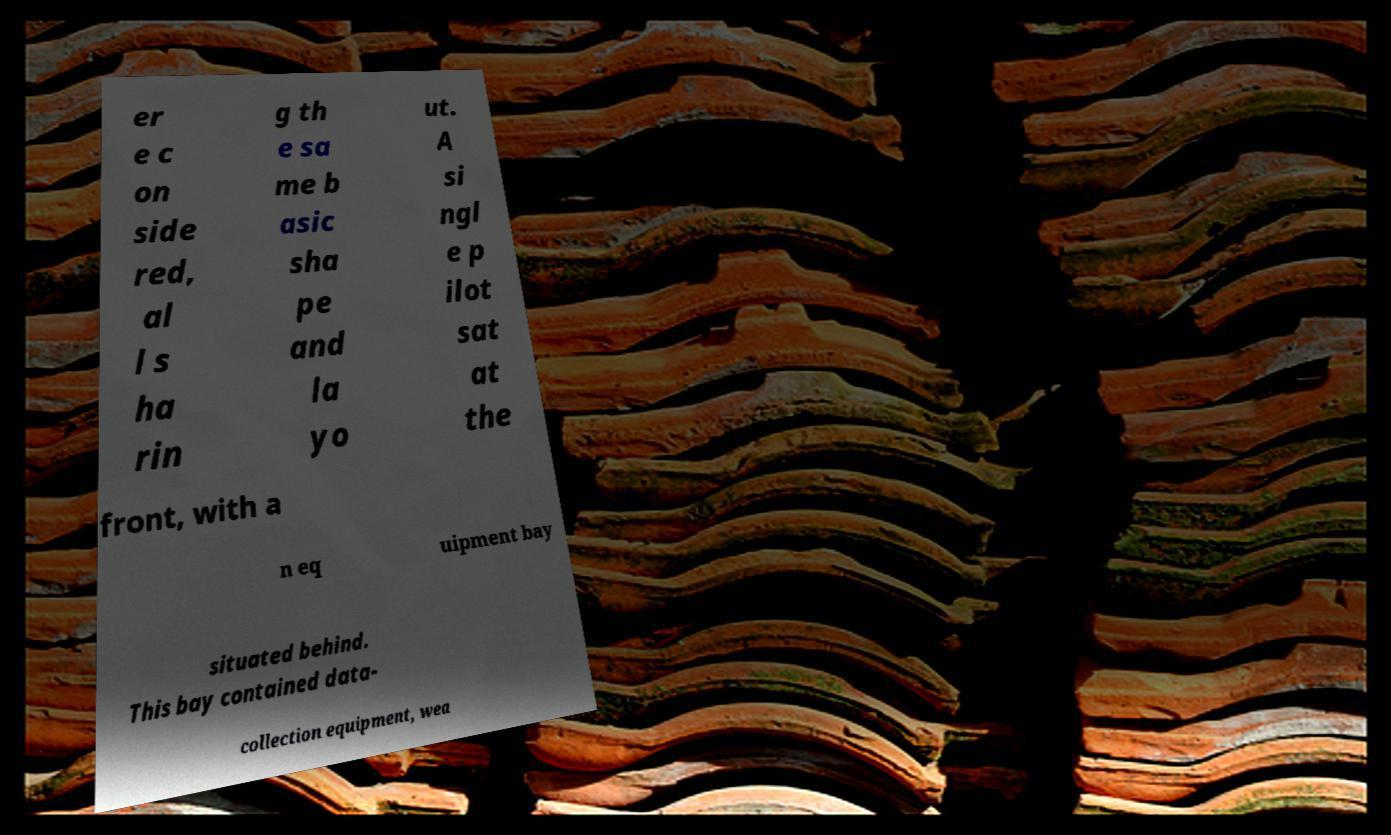Could you assist in decoding the text presented in this image and type it out clearly? er e c on side red, al l s ha rin g th e sa me b asic sha pe and la yo ut. A si ngl e p ilot sat at the front, with a n eq uipment bay situated behind. This bay contained data- collection equipment, wea 